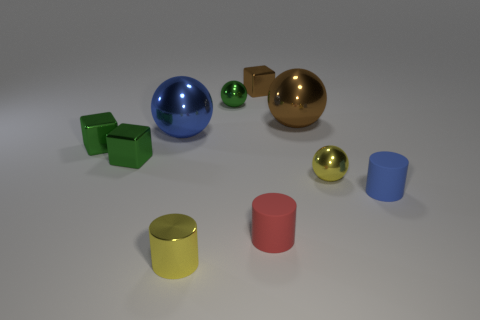Subtract all blue metallic balls. How many balls are left? 3 Subtract all yellow cylinders. How many cylinders are left? 2 Subtract all cylinders. How many objects are left? 7 Subtract 3 cubes. How many cubes are left? 0 Subtract all purple cylinders. How many green blocks are left? 2 Subtract all small gray metallic objects. Subtract all tiny metallic blocks. How many objects are left? 7 Add 7 green metal cubes. How many green metal cubes are left? 9 Add 4 large rubber cylinders. How many large rubber cylinders exist? 4 Subtract 0 yellow cubes. How many objects are left? 10 Subtract all cyan cylinders. Subtract all brown spheres. How many cylinders are left? 3 